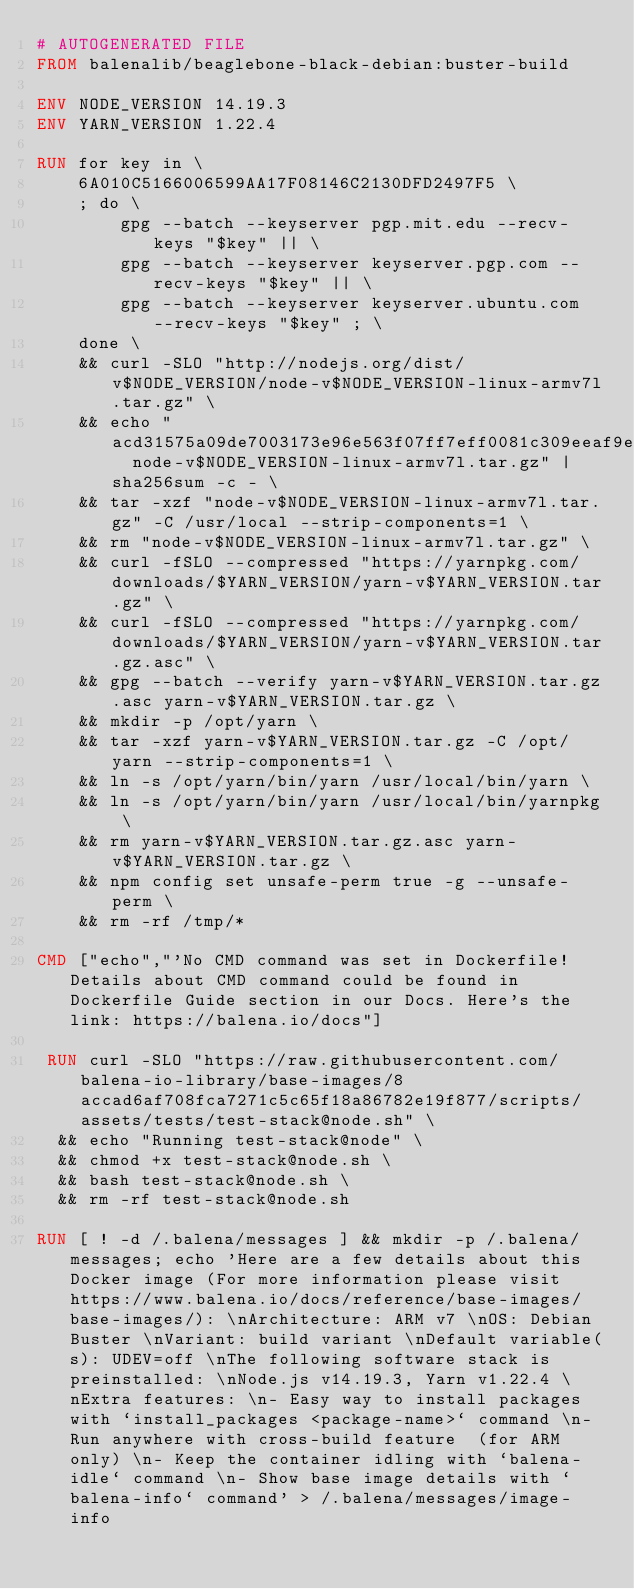<code> <loc_0><loc_0><loc_500><loc_500><_Dockerfile_># AUTOGENERATED FILE
FROM balenalib/beaglebone-black-debian:buster-build

ENV NODE_VERSION 14.19.3
ENV YARN_VERSION 1.22.4

RUN for key in \
	6A010C5166006599AA17F08146C2130DFD2497F5 \
	; do \
		gpg --batch --keyserver pgp.mit.edu --recv-keys "$key" || \
		gpg --batch --keyserver keyserver.pgp.com --recv-keys "$key" || \
		gpg --batch --keyserver keyserver.ubuntu.com --recv-keys "$key" ; \
	done \
	&& curl -SLO "http://nodejs.org/dist/v$NODE_VERSION/node-v$NODE_VERSION-linux-armv7l.tar.gz" \
	&& echo "acd31575a09de7003173e96e563f07ff7eff0081c309eeaf9ead846baa6743ea  node-v$NODE_VERSION-linux-armv7l.tar.gz" | sha256sum -c - \
	&& tar -xzf "node-v$NODE_VERSION-linux-armv7l.tar.gz" -C /usr/local --strip-components=1 \
	&& rm "node-v$NODE_VERSION-linux-armv7l.tar.gz" \
	&& curl -fSLO --compressed "https://yarnpkg.com/downloads/$YARN_VERSION/yarn-v$YARN_VERSION.tar.gz" \
	&& curl -fSLO --compressed "https://yarnpkg.com/downloads/$YARN_VERSION/yarn-v$YARN_VERSION.tar.gz.asc" \
	&& gpg --batch --verify yarn-v$YARN_VERSION.tar.gz.asc yarn-v$YARN_VERSION.tar.gz \
	&& mkdir -p /opt/yarn \
	&& tar -xzf yarn-v$YARN_VERSION.tar.gz -C /opt/yarn --strip-components=1 \
	&& ln -s /opt/yarn/bin/yarn /usr/local/bin/yarn \
	&& ln -s /opt/yarn/bin/yarn /usr/local/bin/yarnpkg \
	&& rm yarn-v$YARN_VERSION.tar.gz.asc yarn-v$YARN_VERSION.tar.gz \
	&& npm config set unsafe-perm true -g --unsafe-perm \
	&& rm -rf /tmp/*

CMD ["echo","'No CMD command was set in Dockerfile! Details about CMD command could be found in Dockerfile Guide section in our Docs. Here's the link: https://balena.io/docs"]

 RUN curl -SLO "https://raw.githubusercontent.com/balena-io-library/base-images/8accad6af708fca7271c5c65f18a86782e19f877/scripts/assets/tests/test-stack@node.sh" \
  && echo "Running test-stack@node" \
  && chmod +x test-stack@node.sh \
  && bash test-stack@node.sh \
  && rm -rf test-stack@node.sh 

RUN [ ! -d /.balena/messages ] && mkdir -p /.balena/messages; echo 'Here are a few details about this Docker image (For more information please visit https://www.balena.io/docs/reference/base-images/base-images/): \nArchitecture: ARM v7 \nOS: Debian Buster \nVariant: build variant \nDefault variable(s): UDEV=off \nThe following software stack is preinstalled: \nNode.js v14.19.3, Yarn v1.22.4 \nExtra features: \n- Easy way to install packages with `install_packages <package-name>` command \n- Run anywhere with cross-build feature  (for ARM only) \n- Keep the container idling with `balena-idle` command \n- Show base image details with `balena-info` command' > /.balena/messages/image-info</code> 